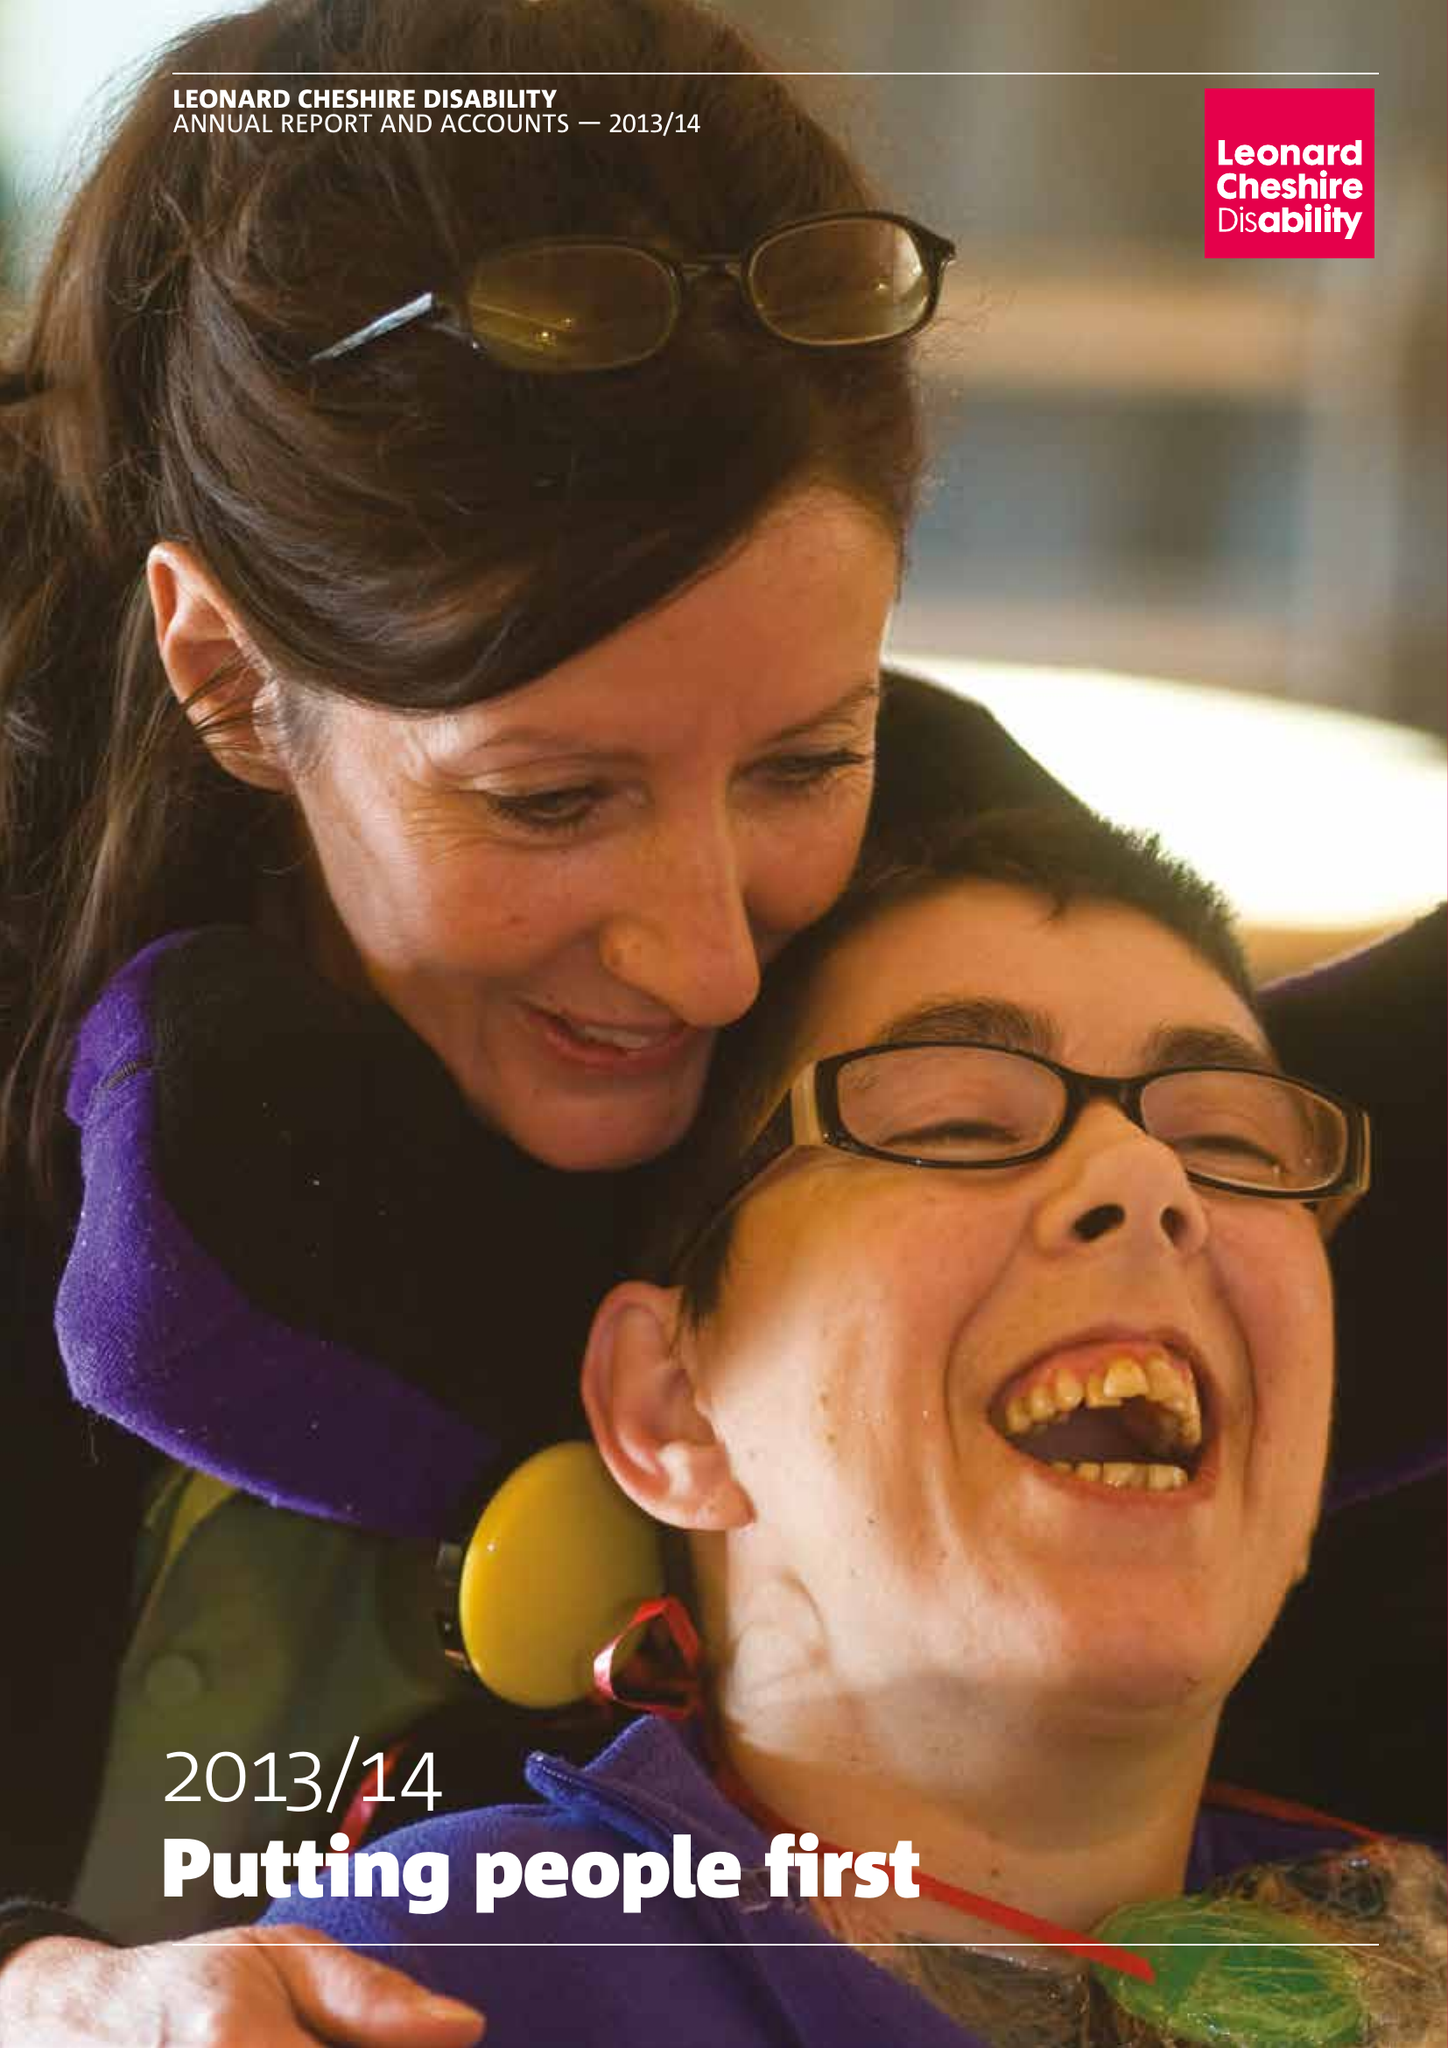What is the value for the report_date?
Answer the question using a single word or phrase. 2014-03-31 